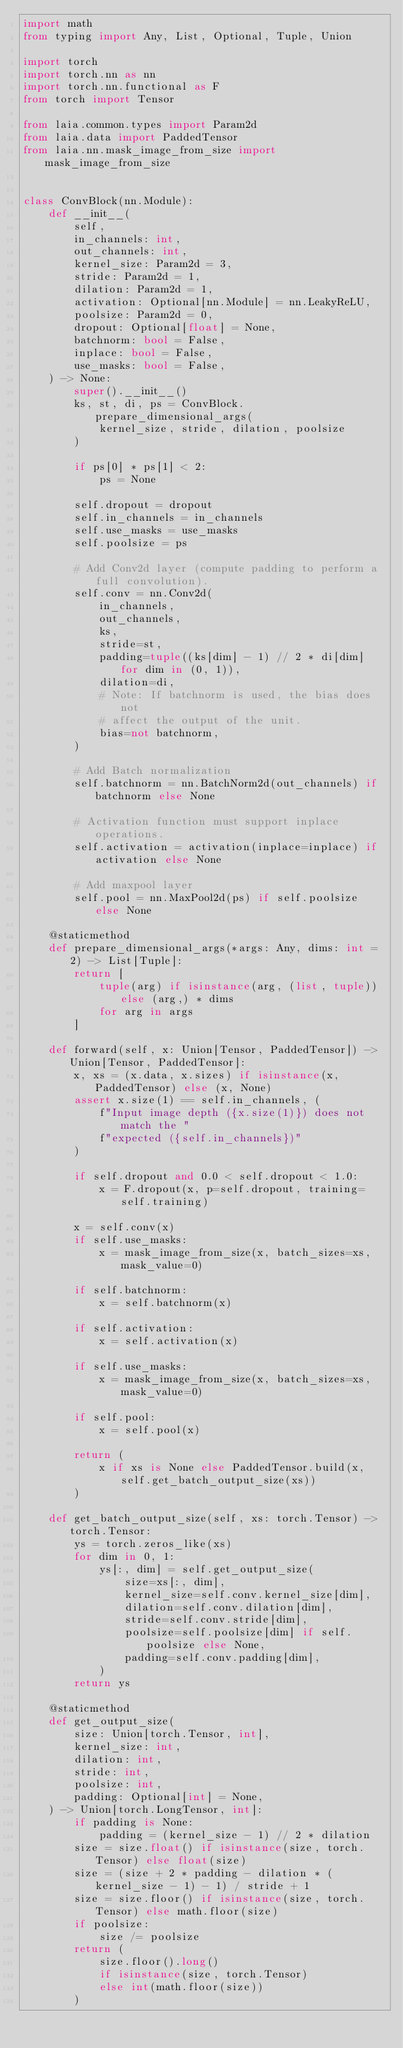Convert code to text. <code><loc_0><loc_0><loc_500><loc_500><_Python_>import math
from typing import Any, List, Optional, Tuple, Union

import torch
import torch.nn as nn
import torch.nn.functional as F
from torch import Tensor

from laia.common.types import Param2d
from laia.data import PaddedTensor
from laia.nn.mask_image_from_size import mask_image_from_size


class ConvBlock(nn.Module):
    def __init__(
        self,
        in_channels: int,
        out_channels: int,
        kernel_size: Param2d = 3,
        stride: Param2d = 1,
        dilation: Param2d = 1,
        activation: Optional[nn.Module] = nn.LeakyReLU,
        poolsize: Param2d = 0,
        dropout: Optional[float] = None,
        batchnorm: bool = False,
        inplace: bool = False,
        use_masks: bool = False,
    ) -> None:
        super().__init__()
        ks, st, di, ps = ConvBlock.prepare_dimensional_args(
            kernel_size, stride, dilation, poolsize
        )

        if ps[0] * ps[1] < 2:
            ps = None

        self.dropout = dropout
        self.in_channels = in_channels
        self.use_masks = use_masks
        self.poolsize = ps

        # Add Conv2d layer (compute padding to perform a full convolution).
        self.conv = nn.Conv2d(
            in_channels,
            out_channels,
            ks,
            stride=st,
            padding=tuple((ks[dim] - 1) // 2 * di[dim] for dim in (0, 1)),
            dilation=di,
            # Note: If batchnorm is used, the bias does not
            # affect the output of the unit.
            bias=not batchnorm,
        )

        # Add Batch normalization
        self.batchnorm = nn.BatchNorm2d(out_channels) if batchnorm else None

        # Activation function must support inplace operations.
        self.activation = activation(inplace=inplace) if activation else None

        # Add maxpool layer
        self.pool = nn.MaxPool2d(ps) if self.poolsize else None

    @staticmethod
    def prepare_dimensional_args(*args: Any, dims: int = 2) -> List[Tuple]:
        return [
            tuple(arg) if isinstance(arg, (list, tuple)) else (arg,) * dims
            for arg in args
        ]

    def forward(self, x: Union[Tensor, PaddedTensor]) -> Union[Tensor, PaddedTensor]:
        x, xs = (x.data, x.sizes) if isinstance(x, PaddedTensor) else (x, None)
        assert x.size(1) == self.in_channels, (
            f"Input image depth ({x.size(1)}) does not match the "
            f"expected ({self.in_channels})"
        )

        if self.dropout and 0.0 < self.dropout < 1.0:
            x = F.dropout(x, p=self.dropout, training=self.training)

        x = self.conv(x)
        if self.use_masks:
            x = mask_image_from_size(x, batch_sizes=xs, mask_value=0)

        if self.batchnorm:
            x = self.batchnorm(x)

        if self.activation:
            x = self.activation(x)

        if self.use_masks:
            x = mask_image_from_size(x, batch_sizes=xs, mask_value=0)

        if self.pool:
            x = self.pool(x)

        return (
            x if xs is None else PaddedTensor.build(x, self.get_batch_output_size(xs))
        )

    def get_batch_output_size(self, xs: torch.Tensor) -> torch.Tensor:
        ys = torch.zeros_like(xs)
        for dim in 0, 1:
            ys[:, dim] = self.get_output_size(
                size=xs[:, dim],
                kernel_size=self.conv.kernel_size[dim],
                dilation=self.conv.dilation[dim],
                stride=self.conv.stride[dim],
                poolsize=self.poolsize[dim] if self.poolsize else None,
                padding=self.conv.padding[dim],
            )
        return ys

    @staticmethod
    def get_output_size(
        size: Union[torch.Tensor, int],
        kernel_size: int,
        dilation: int,
        stride: int,
        poolsize: int,
        padding: Optional[int] = None,
    ) -> Union[torch.LongTensor, int]:
        if padding is None:
            padding = (kernel_size - 1) // 2 * dilation
        size = size.float() if isinstance(size, torch.Tensor) else float(size)
        size = (size + 2 * padding - dilation * (kernel_size - 1) - 1) / stride + 1
        size = size.floor() if isinstance(size, torch.Tensor) else math.floor(size)
        if poolsize:
            size /= poolsize
        return (
            size.floor().long()
            if isinstance(size, torch.Tensor)
            else int(math.floor(size))
        )
</code> 